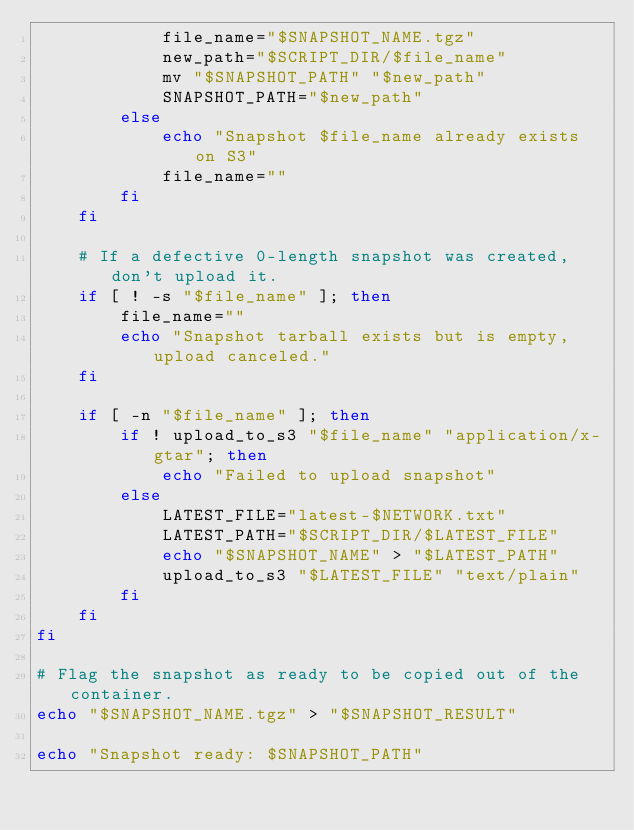<code> <loc_0><loc_0><loc_500><loc_500><_Bash_>            file_name="$SNAPSHOT_NAME.tgz"
            new_path="$SCRIPT_DIR/$file_name"
            mv "$SNAPSHOT_PATH" "$new_path"
            SNAPSHOT_PATH="$new_path"
        else
            echo "Snapshot $file_name already exists on S3"
            file_name=""
        fi
    fi
    
    # If a defective 0-length snapshot was created, don't upload it.
    if [ ! -s "$file_name" ]; then
        file_name=""
        echo "Snapshot tarball exists but is empty, upload canceled."
    fi

    if [ -n "$file_name" ]; then
        if ! upload_to_s3 "$file_name" "application/x-gtar"; then
            echo "Failed to upload snapshot"
        else
            LATEST_FILE="latest-$NETWORK.txt"
            LATEST_PATH="$SCRIPT_DIR/$LATEST_FILE"
            echo "$SNAPSHOT_NAME" > "$LATEST_PATH"
            upload_to_s3 "$LATEST_FILE" "text/plain"
        fi
    fi
fi

# Flag the snapshot as ready to be copied out of the container.
echo "$SNAPSHOT_NAME.tgz" > "$SNAPSHOT_RESULT"

echo "Snapshot ready: $SNAPSHOT_PATH"
</code> 